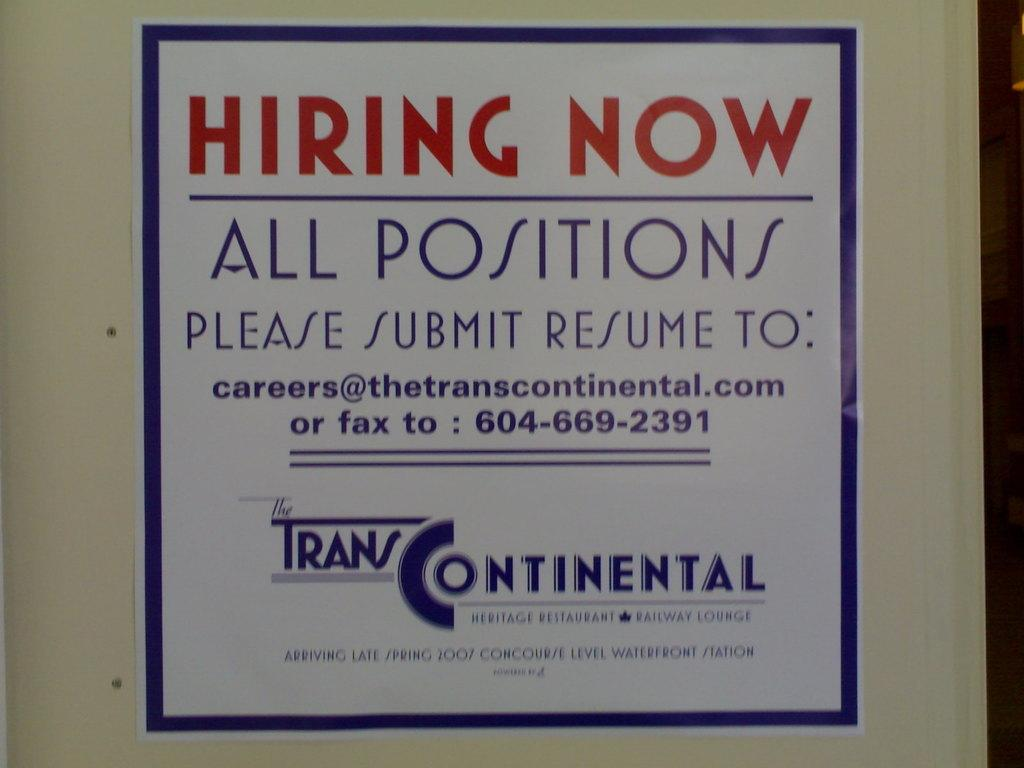Provide a one-sentence caption for the provided image. A poster advertising open job positions for Trans Continental. 